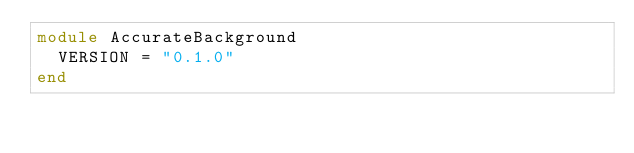Convert code to text. <code><loc_0><loc_0><loc_500><loc_500><_Ruby_>module AccurateBackground
  VERSION = "0.1.0"
end
</code> 